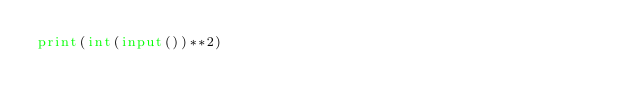<code> <loc_0><loc_0><loc_500><loc_500><_Python_>print(int(input())**2)</code> 